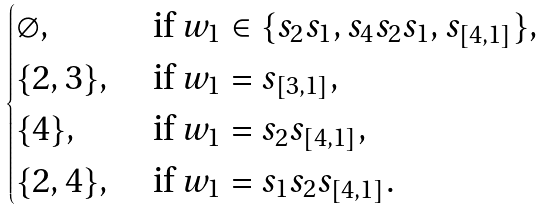<formula> <loc_0><loc_0><loc_500><loc_500>\begin{cases} \varnothing , & \text { if } w _ { 1 } \in \{ s _ { 2 } s _ { 1 } , s _ { 4 } s _ { 2 } s _ { 1 } , s _ { [ 4 , 1 ] } \} , \\ \{ 2 , 3 \} , & \text { if } w _ { 1 } = s _ { [ 3 , 1 ] } , \\ \{ 4 \} , & \text { if } w _ { 1 } = s _ { 2 } s _ { [ 4 , 1 ] } , \\ \{ 2 , 4 \} , & \text { if } w _ { 1 } = s _ { 1 } s _ { 2 } s _ { [ 4 , 1 ] } . \end{cases}</formula> 